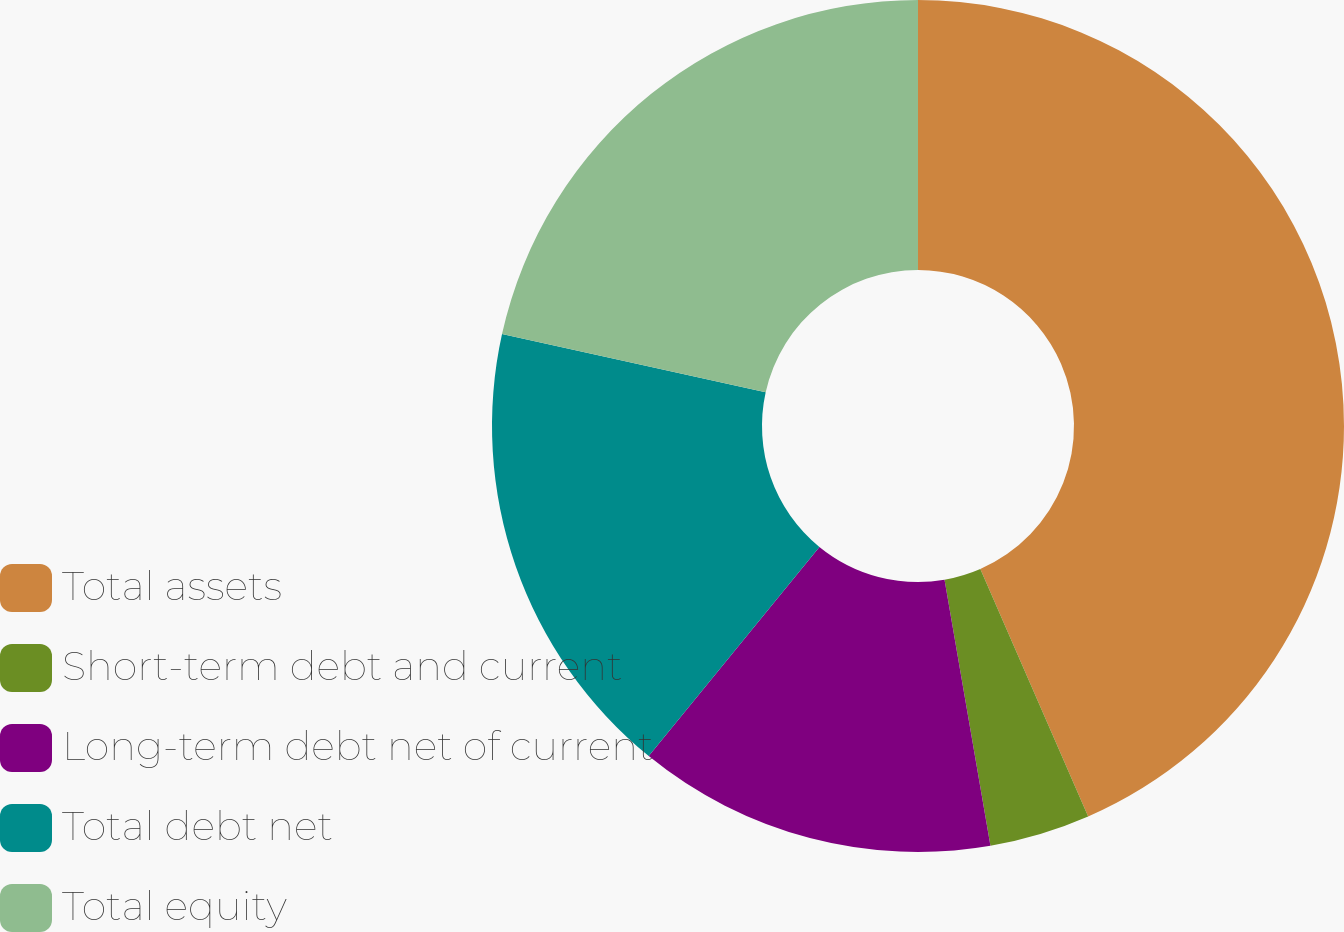<chart> <loc_0><loc_0><loc_500><loc_500><pie_chart><fcel>Total assets<fcel>Short-term debt and current<fcel>Long-term debt net of current<fcel>Total debt net<fcel>Total equity<nl><fcel>43.46%<fcel>3.82%<fcel>13.61%<fcel>17.57%<fcel>21.54%<nl></chart> 